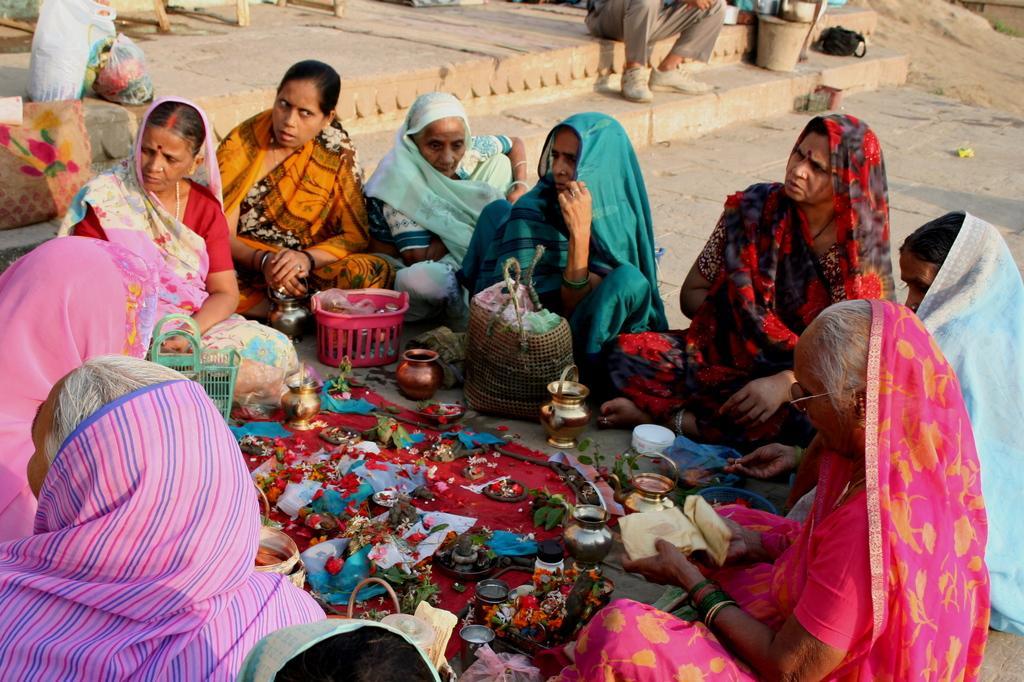In one or two sentences, can you explain what this image depicts? In this image, I can see a group of people women sitting. These are the baskets. I can the flowers, clothes and few other objects are placed on the floor. At the top of the image, I can see a person sitting. This looks like a bucket and a bag. On the left side of the image, I can see the bags. 